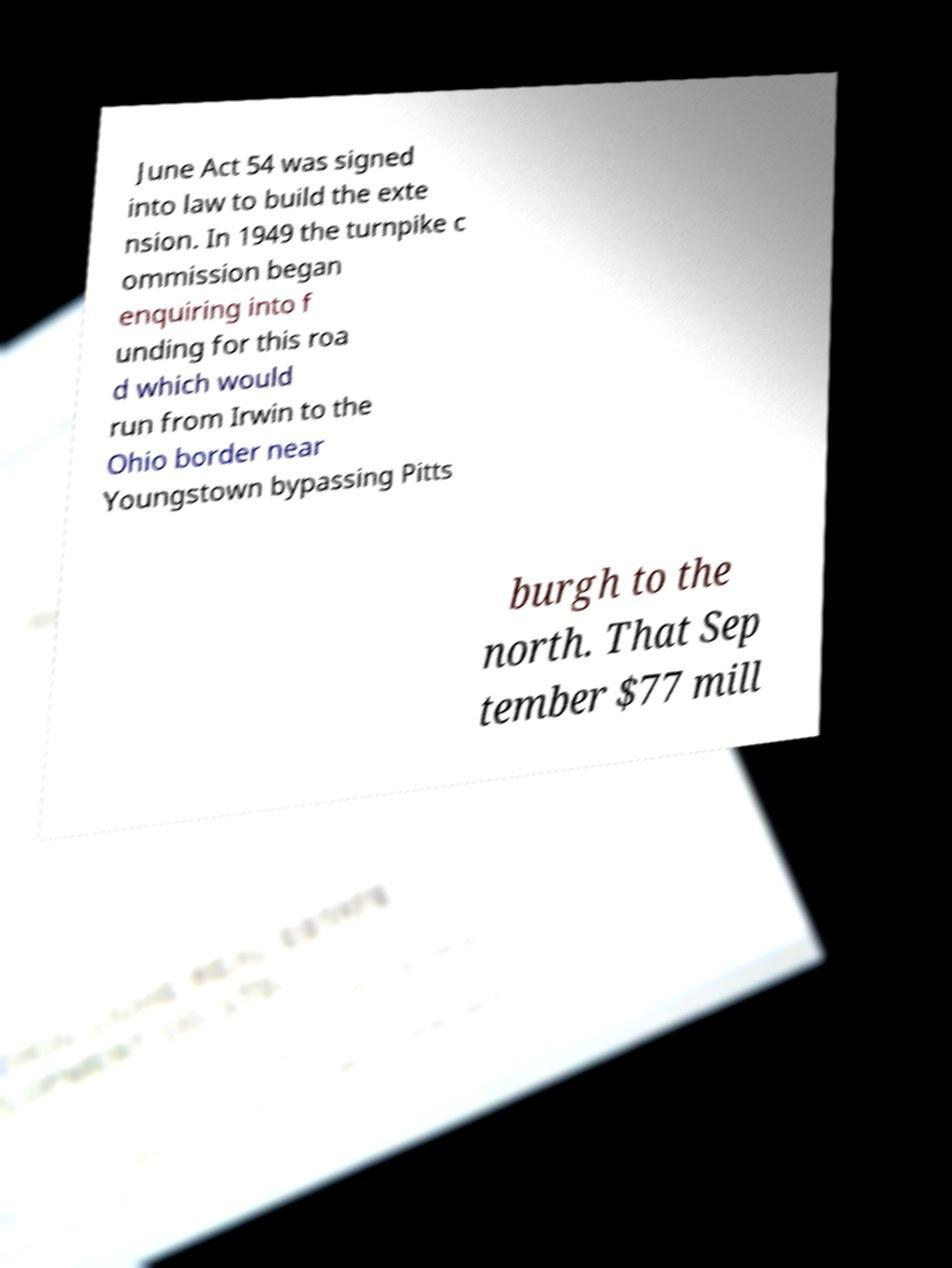Can you read and provide the text displayed in the image?This photo seems to have some interesting text. Can you extract and type it out for me? June Act 54 was signed into law to build the exte nsion. In 1949 the turnpike c ommission began enquiring into f unding for this roa d which would run from Irwin to the Ohio border near Youngstown bypassing Pitts burgh to the north. That Sep tember $77 mill 